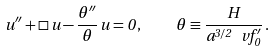Convert formula to latex. <formula><loc_0><loc_0><loc_500><loc_500>u ^ { \prime \prime } + \Box \, u - \frac { \theta ^ { \prime \prime } } { \theta } \, u = 0 \, , \quad \theta \equiv \frac { H } { a ^ { 3 / 2 } \, \ v f _ { 0 } ^ { \prime } } \, .</formula> 